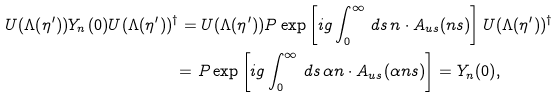Convert formula to latex. <formula><loc_0><loc_0><loc_500><loc_500>U ( \Lambda ( \eta ^ { \prime } ) ) Y _ { n } ( 0 ) U ( \Lambda ( \eta ^ { \prime } ) ) ^ { \dag } & = U ( \Lambda ( \eta ^ { \prime } ) ) P \exp \left [ i g \int _ { 0 } ^ { \infty } \, d s \, n \cdot A _ { u s } ( n s ) \right ] U ( \Lambda ( \eta ^ { \prime } ) ) ^ { \dag } \\ & { = } \ P \exp \left [ i g \int _ { 0 } ^ { \infty } \, d s \, \alpha n \cdot A _ { u s } ( \alpha n s ) \right ] = Y _ { n } ( 0 ) ,</formula> 